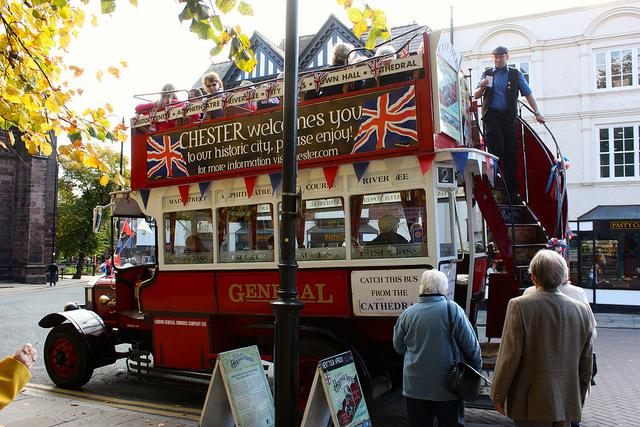The flag on the bus belongs to which Country? Please explain your reasoning. united kingdom. The flag has red and white crosses on a blue background. it is the union jack. 